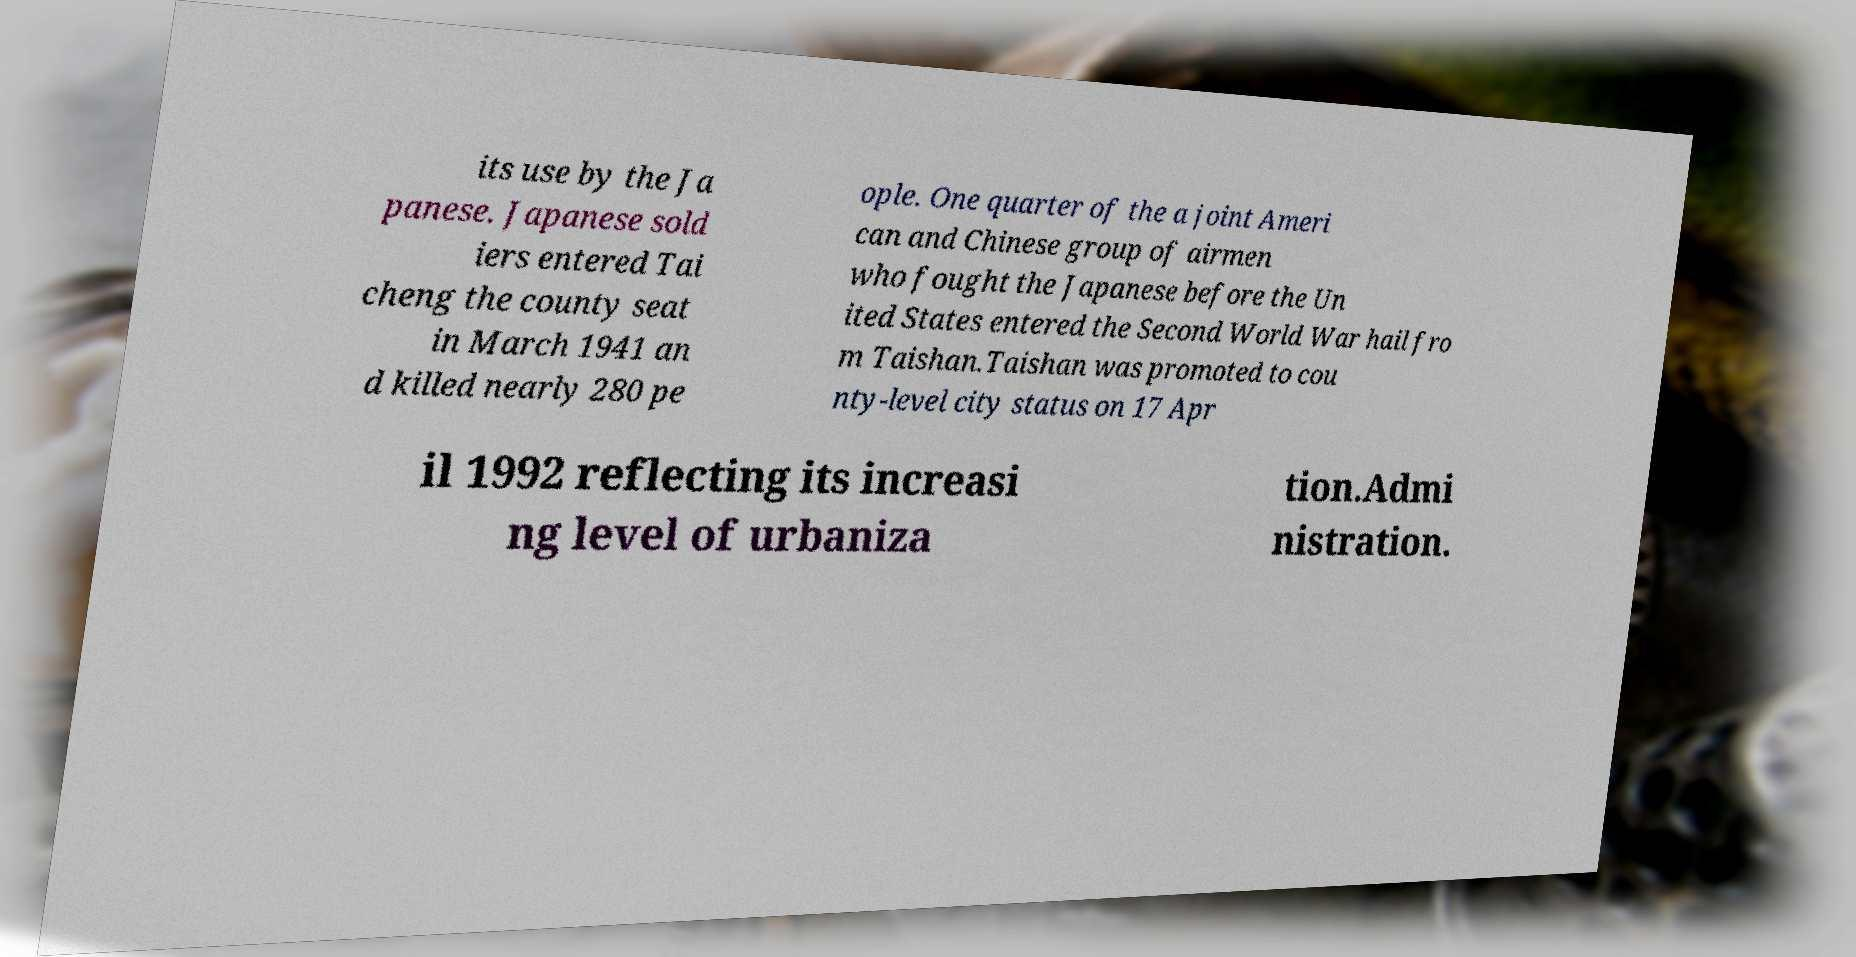Can you accurately transcribe the text from the provided image for me? its use by the Ja panese. Japanese sold iers entered Tai cheng the county seat in March 1941 an d killed nearly 280 pe ople. One quarter of the a joint Ameri can and Chinese group of airmen who fought the Japanese before the Un ited States entered the Second World War hail fro m Taishan.Taishan was promoted to cou nty-level city status on 17 Apr il 1992 reflecting its increasi ng level of urbaniza tion.Admi nistration. 